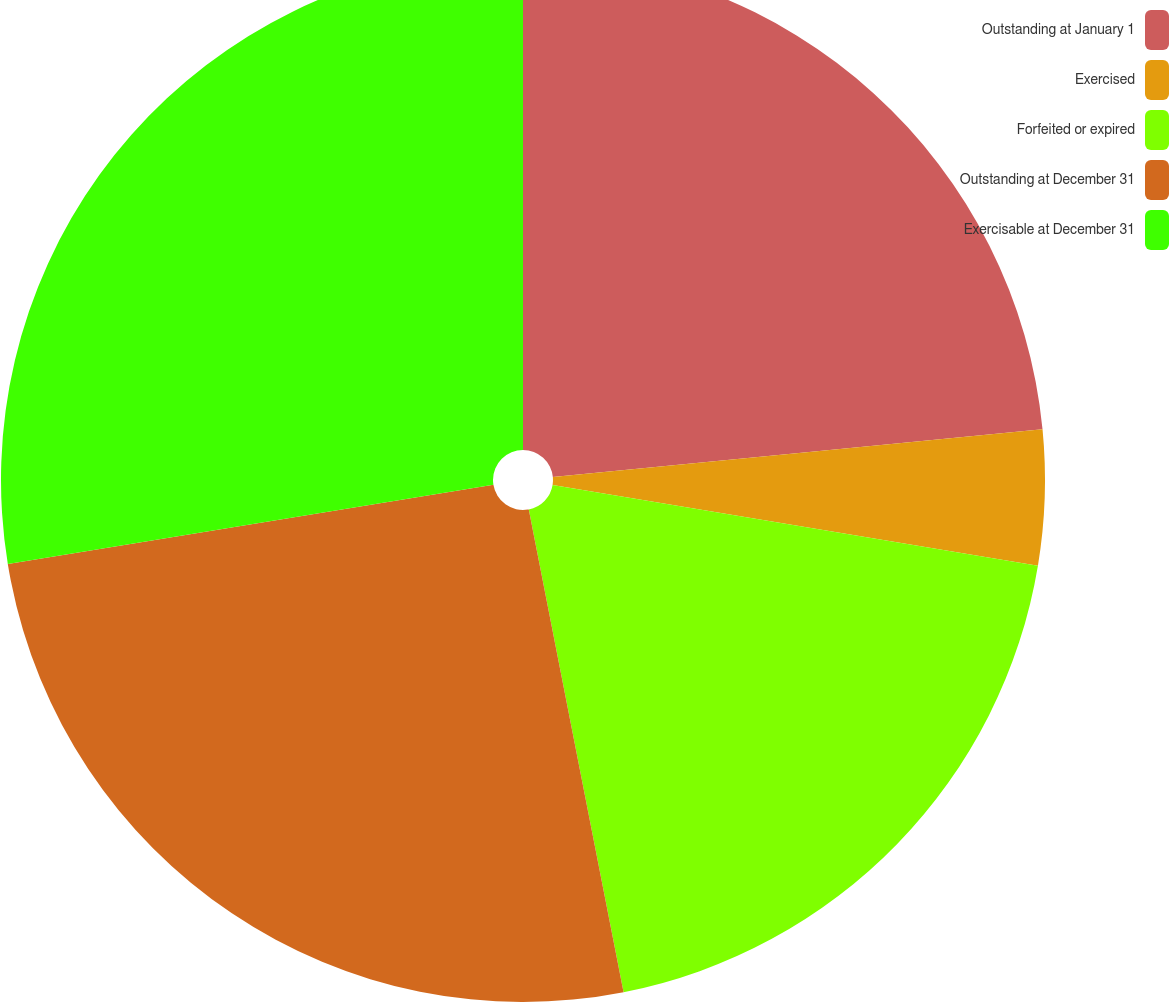Convert chart. <chart><loc_0><loc_0><loc_500><loc_500><pie_chart><fcel>Outstanding at January 1<fcel>Exercised<fcel>Forfeited or expired<fcel>Outstanding at December 31<fcel>Exercisable at December 31<nl><fcel>23.45%<fcel>4.17%<fcel>19.29%<fcel>25.51%<fcel>27.57%<nl></chart> 